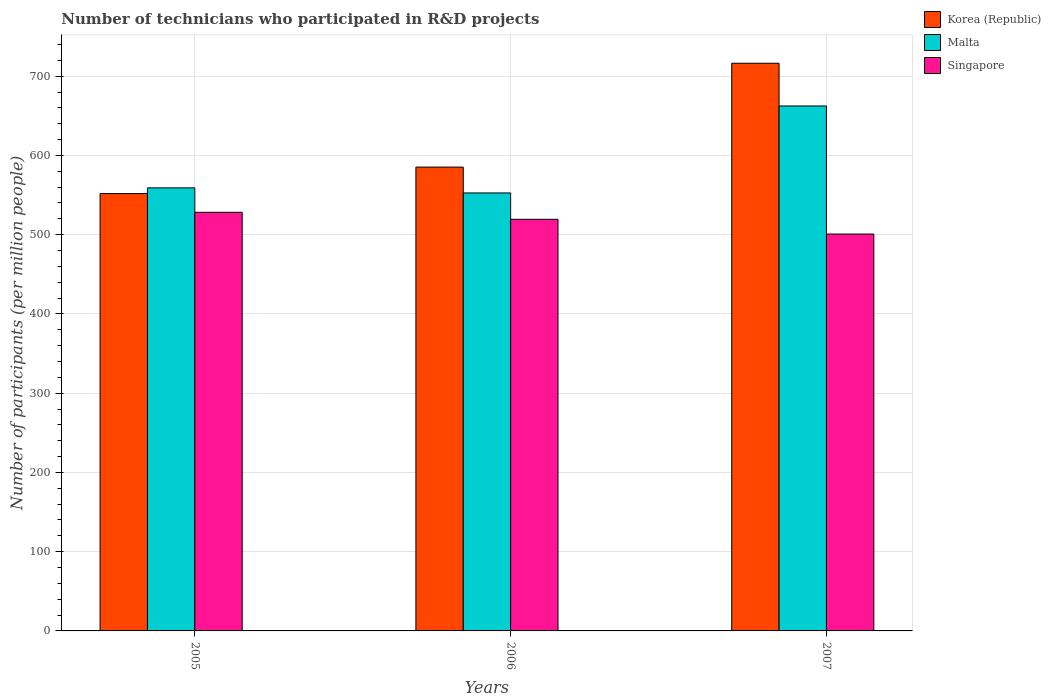Are the number of bars per tick equal to the number of legend labels?
Provide a short and direct response. Yes. Are the number of bars on each tick of the X-axis equal?
Provide a succinct answer. Yes. How many bars are there on the 2nd tick from the right?
Give a very brief answer. 3. What is the label of the 1st group of bars from the left?
Keep it short and to the point. 2005. In how many cases, is the number of bars for a given year not equal to the number of legend labels?
Your answer should be very brief. 0. What is the number of technicians who participated in R&D projects in Korea (Republic) in 2005?
Provide a succinct answer. 551.85. Across all years, what is the maximum number of technicians who participated in R&D projects in Singapore?
Offer a very short reply. 528.23. Across all years, what is the minimum number of technicians who participated in R&D projects in Malta?
Give a very brief answer. 552.65. In which year was the number of technicians who participated in R&D projects in Singapore maximum?
Offer a very short reply. 2005. What is the total number of technicians who participated in R&D projects in Singapore in the graph?
Your answer should be very brief. 1548.41. What is the difference between the number of technicians who participated in R&D projects in Singapore in 2005 and that in 2007?
Keep it short and to the point. 27.44. What is the difference between the number of technicians who participated in R&D projects in Malta in 2005 and the number of technicians who participated in R&D projects in Korea (Republic) in 2006?
Provide a succinct answer. -26.21. What is the average number of technicians who participated in R&D projects in Singapore per year?
Keep it short and to the point. 516.14. In the year 2007, what is the difference between the number of technicians who participated in R&D projects in Korea (Republic) and number of technicians who participated in R&D projects in Malta?
Offer a very short reply. 53.89. What is the ratio of the number of technicians who participated in R&D projects in Singapore in 2005 to that in 2006?
Make the answer very short. 1.02. Is the number of technicians who participated in R&D projects in Singapore in 2006 less than that in 2007?
Offer a terse response. No. What is the difference between the highest and the second highest number of technicians who participated in R&D projects in Korea (Republic)?
Offer a terse response. 131.03. What is the difference between the highest and the lowest number of technicians who participated in R&D projects in Malta?
Ensure brevity in your answer.  109.76. What does the 2nd bar from the left in 2005 represents?
Give a very brief answer. Malta. What does the 1st bar from the right in 2007 represents?
Keep it short and to the point. Singapore. How many years are there in the graph?
Give a very brief answer. 3. What is the difference between two consecutive major ticks on the Y-axis?
Your answer should be very brief. 100. Are the values on the major ticks of Y-axis written in scientific E-notation?
Offer a terse response. No. Does the graph contain any zero values?
Give a very brief answer. No. Does the graph contain grids?
Offer a very short reply. Yes. What is the title of the graph?
Keep it short and to the point. Number of technicians who participated in R&D projects. Does "American Samoa" appear as one of the legend labels in the graph?
Provide a succinct answer. No. What is the label or title of the Y-axis?
Offer a very short reply. Number of participants (per million people). What is the Number of participants (per million people) in Korea (Republic) in 2005?
Offer a terse response. 551.85. What is the Number of participants (per million people) of Malta in 2005?
Ensure brevity in your answer.  559.06. What is the Number of participants (per million people) in Singapore in 2005?
Your answer should be very brief. 528.23. What is the Number of participants (per million people) in Korea (Republic) in 2006?
Keep it short and to the point. 585.27. What is the Number of participants (per million people) of Malta in 2006?
Your answer should be very brief. 552.65. What is the Number of participants (per million people) in Singapore in 2006?
Your answer should be very brief. 519.4. What is the Number of participants (per million people) in Korea (Republic) in 2007?
Make the answer very short. 716.3. What is the Number of participants (per million people) of Malta in 2007?
Offer a terse response. 662.41. What is the Number of participants (per million people) of Singapore in 2007?
Ensure brevity in your answer.  500.79. Across all years, what is the maximum Number of participants (per million people) in Korea (Republic)?
Provide a short and direct response. 716.3. Across all years, what is the maximum Number of participants (per million people) in Malta?
Offer a very short reply. 662.41. Across all years, what is the maximum Number of participants (per million people) in Singapore?
Your response must be concise. 528.23. Across all years, what is the minimum Number of participants (per million people) in Korea (Republic)?
Give a very brief answer. 551.85. Across all years, what is the minimum Number of participants (per million people) of Malta?
Offer a very short reply. 552.65. Across all years, what is the minimum Number of participants (per million people) in Singapore?
Provide a succinct answer. 500.79. What is the total Number of participants (per million people) in Korea (Republic) in the graph?
Ensure brevity in your answer.  1853.43. What is the total Number of participants (per million people) of Malta in the graph?
Your response must be concise. 1774.12. What is the total Number of participants (per million people) in Singapore in the graph?
Offer a very short reply. 1548.41. What is the difference between the Number of participants (per million people) in Korea (Republic) in 2005 and that in 2006?
Offer a very short reply. -33.42. What is the difference between the Number of participants (per million people) of Malta in 2005 and that in 2006?
Your response must be concise. 6.41. What is the difference between the Number of participants (per million people) in Singapore in 2005 and that in 2006?
Your answer should be compact. 8.83. What is the difference between the Number of participants (per million people) in Korea (Republic) in 2005 and that in 2007?
Your answer should be very brief. -164.45. What is the difference between the Number of participants (per million people) in Malta in 2005 and that in 2007?
Provide a succinct answer. -103.34. What is the difference between the Number of participants (per million people) in Singapore in 2005 and that in 2007?
Offer a very short reply. 27.44. What is the difference between the Number of participants (per million people) in Korea (Republic) in 2006 and that in 2007?
Your answer should be very brief. -131.03. What is the difference between the Number of participants (per million people) in Malta in 2006 and that in 2007?
Your response must be concise. -109.76. What is the difference between the Number of participants (per million people) of Singapore in 2006 and that in 2007?
Ensure brevity in your answer.  18.62. What is the difference between the Number of participants (per million people) of Korea (Republic) in 2005 and the Number of participants (per million people) of Malta in 2006?
Make the answer very short. -0.79. What is the difference between the Number of participants (per million people) of Korea (Republic) in 2005 and the Number of participants (per million people) of Singapore in 2006?
Offer a very short reply. 32.45. What is the difference between the Number of participants (per million people) in Malta in 2005 and the Number of participants (per million people) in Singapore in 2006?
Provide a succinct answer. 39.66. What is the difference between the Number of participants (per million people) of Korea (Republic) in 2005 and the Number of participants (per million people) of Malta in 2007?
Your answer should be compact. -110.55. What is the difference between the Number of participants (per million people) in Korea (Republic) in 2005 and the Number of participants (per million people) in Singapore in 2007?
Make the answer very short. 51.07. What is the difference between the Number of participants (per million people) in Malta in 2005 and the Number of participants (per million people) in Singapore in 2007?
Your answer should be very brief. 58.28. What is the difference between the Number of participants (per million people) of Korea (Republic) in 2006 and the Number of participants (per million people) of Malta in 2007?
Keep it short and to the point. -77.13. What is the difference between the Number of participants (per million people) of Korea (Republic) in 2006 and the Number of participants (per million people) of Singapore in 2007?
Give a very brief answer. 84.49. What is the difference between the Number of participants (per million people) of Malta in 2006 and the Number of participants (per million people) of Singapore in 2007?
Your answer should be compact. 51.86. What is the average Number of participants (per million people) in Korea (Republic) per year?
Provide a succinct answer. 617.81. What is the average Number of participants (per million people) of Malta per year?
Your answer should be compact. 591.37. What is the average Number of participants (per million people) of Singapore per year?
Your answer should be very brief. 516.14. In the year 2005, what is the difference between the Number of participants (per million people) of Korea (Republic) and Number of participants (per million people) of Malta?
Your answer should be compact. -7.21. In the year 2005, what is the difference between the Number of participants (per million people) in Korea (Republic) and Number of participants (per million people) in Singapore?
Offer a terse response. 23.63. In the year 2005, what is the difference between the Number of participants (per million people) of Malta and Number of participants (per million people) of Singapore?
Offer a terse response. 30.83. In the year 2006, what is the difference between the Number of participants (per million people) of Korea (Republic) and Number of participants (per million people) of Malta?
Offer a very short reply. 32.62. In the year 2006, what is the difference between the Number of participants (per million people) of Korea (Republic) and Number of participants (per million people) of Singapore?
Provide a short and direct response. 65.87. In the year 2006, what is the difference between the Number of participants (per million people) in Malta and Number of participants (per million people) in Singapore?
Provide a succinct answer. 33.25. In the year 2007, what is the difference between the Number of participants (per million people) of Korea (Republic) and Number of participants (per million people) of Malta?
Keep it short and to the point. 53.89. In the year 2007, what is the difference between the Number of participants (per million people) of Korea (Republic) and Number of participants (per million people) of Singapore?
Your answer should be compact. 215.51. In the year 2007, what is the difference between the Number of participants (per million people) of Malta and Number of participants (per million people) of Singapore?
Offer a very short reply. 161.62. What is the ratio of the Number of participants (per million people) in Korea (Republic) in 2005 to that in 2006?
Offer a terse response. 0.94. What is the ratio of the Number of participants (per million people) of Malta in 2005 to that in 2006?
Your answer should be very brief. 1.01. What is the ratio of the Number of participants (per million people) in Korea (Republic) in 2005 to that in 2007?
Offer a terse response. 0.77. What is the ratio of the Number of participants (per million people) in Malta in 2005 to that in 2007?
Ensure brevity in your answer.  0.84. What is the ratio of the Number of participants (per million people) of Singapore in 2005 to that in 2007?
Your answer should be compact. 1.05. What is the ratio of the Number of participants (per million people) in Korea (Republic) in 2006 to that in 2007?
Offer a very short reply. 0.82. What is the ratio of the Number of participants (per million people) of Malta in 2006 to that in 2007?
Offer a terse response. 0.83. What is the ratio of the Number of participants (per million people) in Singapore in 2006 to that in 2007?
Provide a succinct answer. 1.04. What is the difference between the highest and the second highest Number of participants (per million people) in Korea (Republic)?
Your response must be concise. 131.03. What is the difference between the highest and the second highest Number of participants (per million people) in Malta?
Make the answer very short. 103.34. What is the difference between the highest and the second highest Number of participants (per million people) of Singapore?
Provide a succinct answer. 8.83. What is the difference between the highest and the lowest Number of participants (per million people) in Korea (Republic)?
Ensure brevity in your answer.  164.45. What is the difference between the highest and the lowest Number of participants (per million people) of Malta?
Ensure brevity in your answer.  109.76. What is the difference between the highest and the lowest Number of participants (per million people) of Singapore?
Your answer should be very brief. 27.44. 